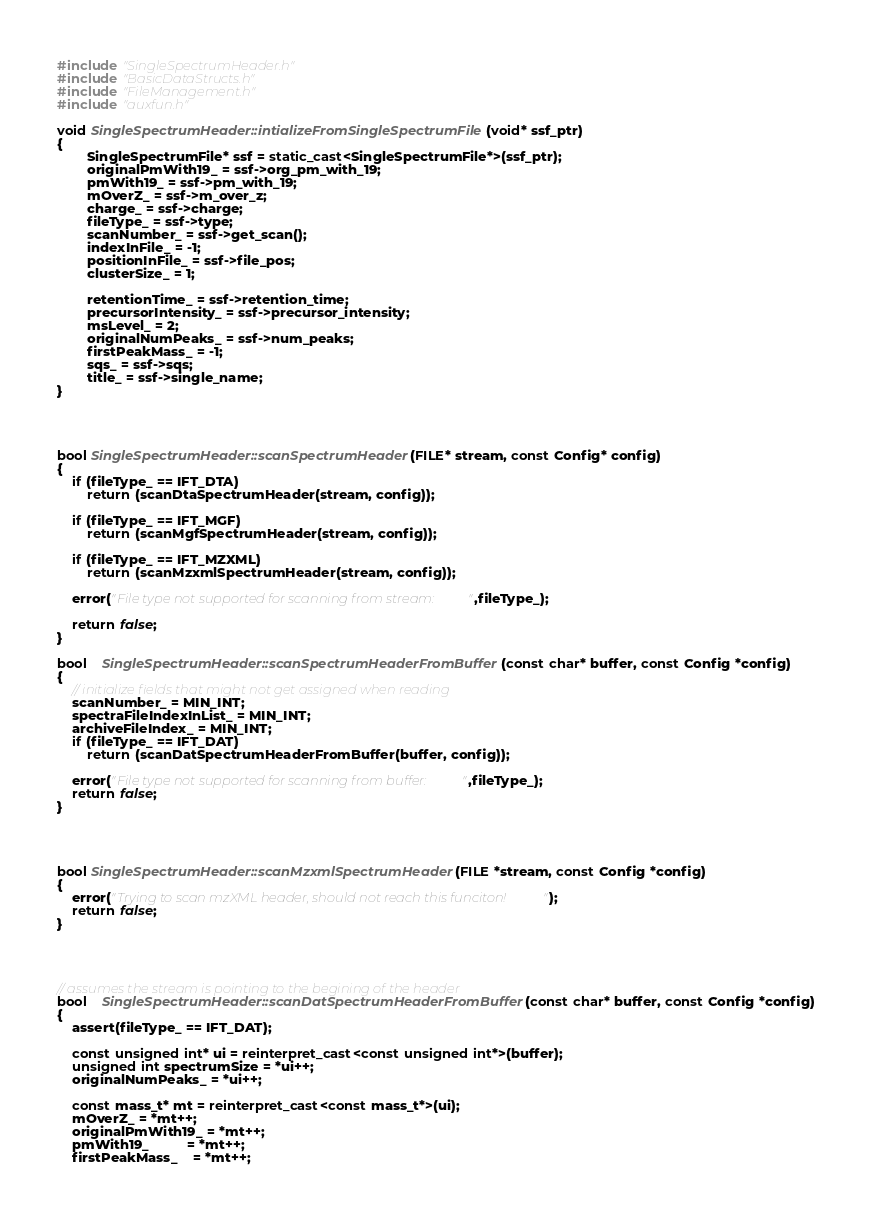Convert code to text. <code><loc_0><loc_0><loc_500><loc_500><_C++_>#include "SingleSpectrumHeader.h"
#include "BasicDataStructs.h"
#include "FileManagement.h"
#include "auxfun.h"

void SingleSpectrumHeader::intializeFromSingleSpectrumFile(void* ssf_ptr)
{
        SingleSpectrumFile* ssf = static_cast<SingleSpectrumFile*>(ssf_ptr);
        originalPmWith19_ = ssf->org_pm_with_19;
        pmWith19_ = ssf->pm_with_19;
        mOverZ_ = ssf->m_over_z;
        charge_ = ssf->charge;
        fileType_ = ssf->type;
        scanNumber_ = ssf->get_scan();
        indexInFile_ = -1;
        positionInFile_ = ssf->file_pos;
        clusterSize_ = 1;
 
        retentionTime_ = ssf->retention_time;
        precursorIntensity_ = ssf->precursor_intensity;
        msLevel_ = 2;
        originalNumPeaks_ = ssf->num_peaks;
        firstPeakMass_ = -1;
        sqs_ = ssf->sqs;
        title_ = ssf->single_name;
}




bool SingleSpectrumHeader::scanSpectrumHeader(FILE* stream, const Config* config)
{
	if (fileType_ == IFT_DTA)
		return (scanDtaSpectrumHeader(stream, config));

	if (fileType_ == IFT_MGF)
		return (scanMgfSpectrumHeader(stream, config));

	if (fileType_ == IFT_MZXML)
		return (scanMzxmlSpectrumHeader(stream, config));

	error("File type not supported for scanning from stream: ",fileType_);

	return false;
}

bool	SingleSpectrumHeader::scanSpectrumHeaderFromBuffer(const char* buffer, const Config *config)
{
	// initialize fields that might not get assigned when reading
	scanNumber_ = MIN_INT;
	spectraFileIndexInList_ = MIN_INT;
	archiveFileIndex_ = MIN_INT;
	if (fileType_ == IFT_DAT)
		return (scanDatSpectrumHeaderFromBuffer(buffer, config));

	error("File type not supported for scanning from buffer: ",fileType_);
	return false;
}




bool SingleSpectrumHeader::scanMzxmlSpectrumHeader(FILE *stream, const Config *config)
{
	error("Trying to scan mzXML header, should not reach this funciton!");
	return false;
}




// assumes the stream is pointing to the begining of the header
bool	SingleSpectrumHeader::scanDatSpectrumHeaderFromBuffer(const char* buffer, const Config *config)
{
	assert(fileType_ == IFT_DAT);

	const unsigned int* ui = reinterpret_cast<const unsigned int*>(buffer);
	unsigned int spectrumSize = *ui++;
	originalNumPeaks_ = *ui++;
	
	const mass_t* mt = reinterpret_cast<const mass_t*>(ui);
	mOverZ_ = *mt++;
	originalPmWith19_ = *mt++;
	pmWith19_		  = *mt++;
	firstPeakMass_    = *mt++;
</code> 